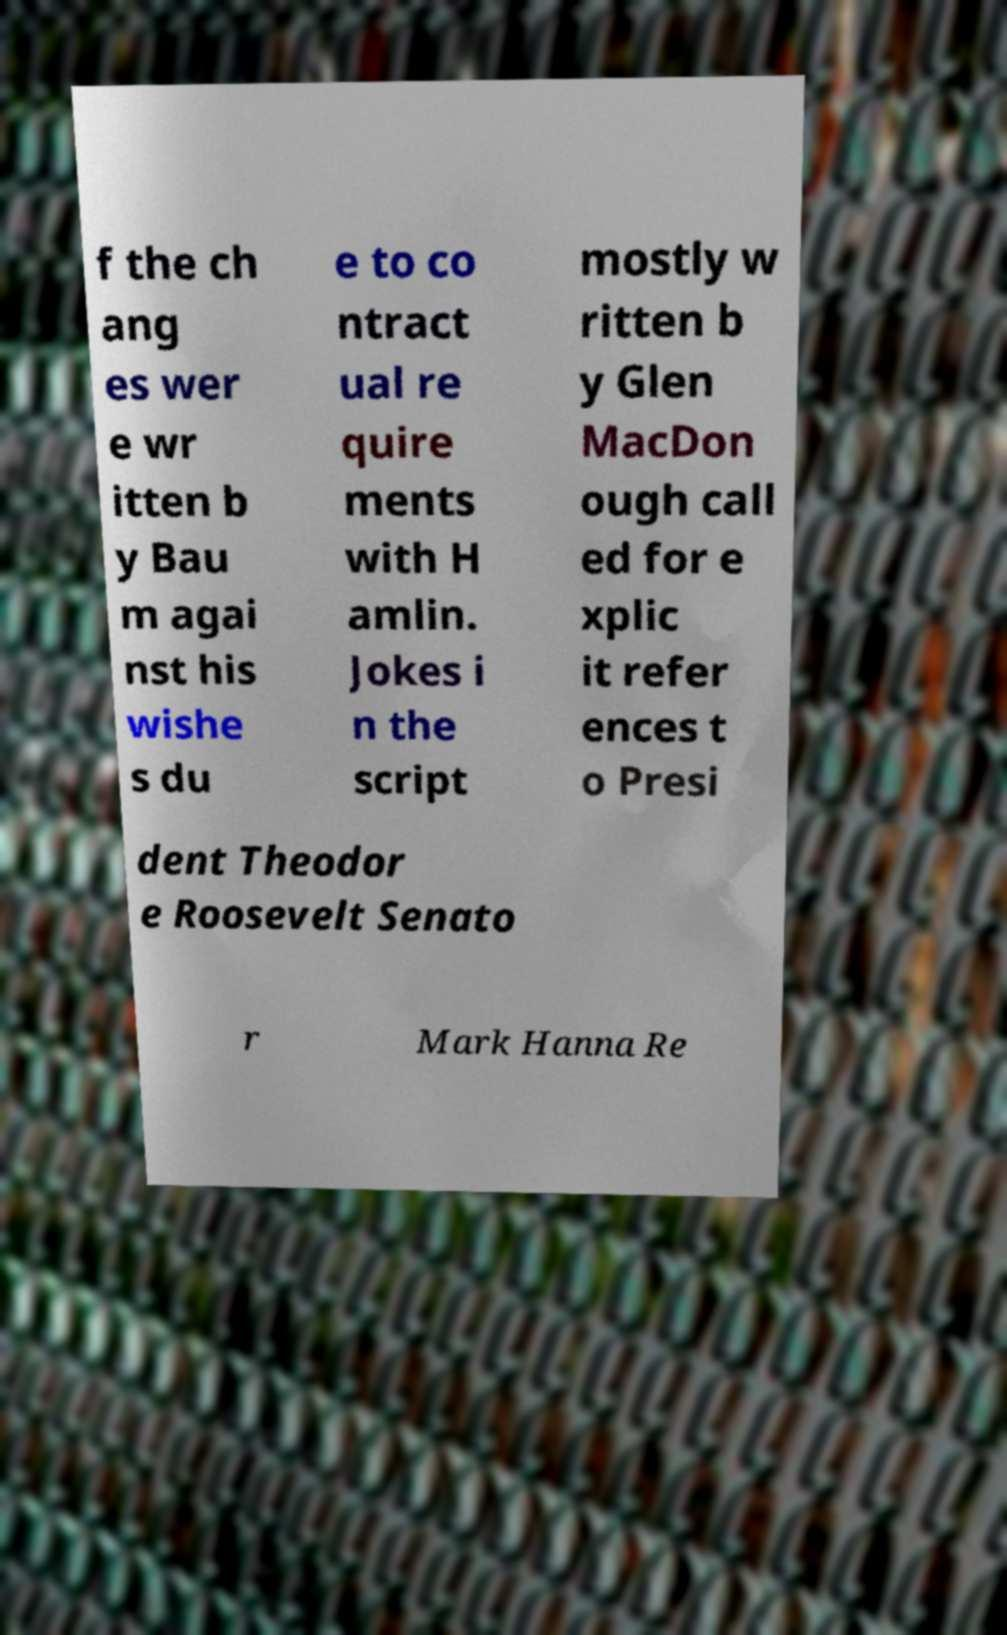What messages or text are displayed in this image? I need them in a readable, typed format. f the ch ang es wer e wr itten b y Bau m agai nst his wishe s du e to co ntract ual re quire ments with H amlin. Jokes i n the script mostly w ritten b y Glen MacDon ough call ed for e xplic it refer ences t o Presi dent Theodor e Roosevelt Senato r Mark Hanna Re 